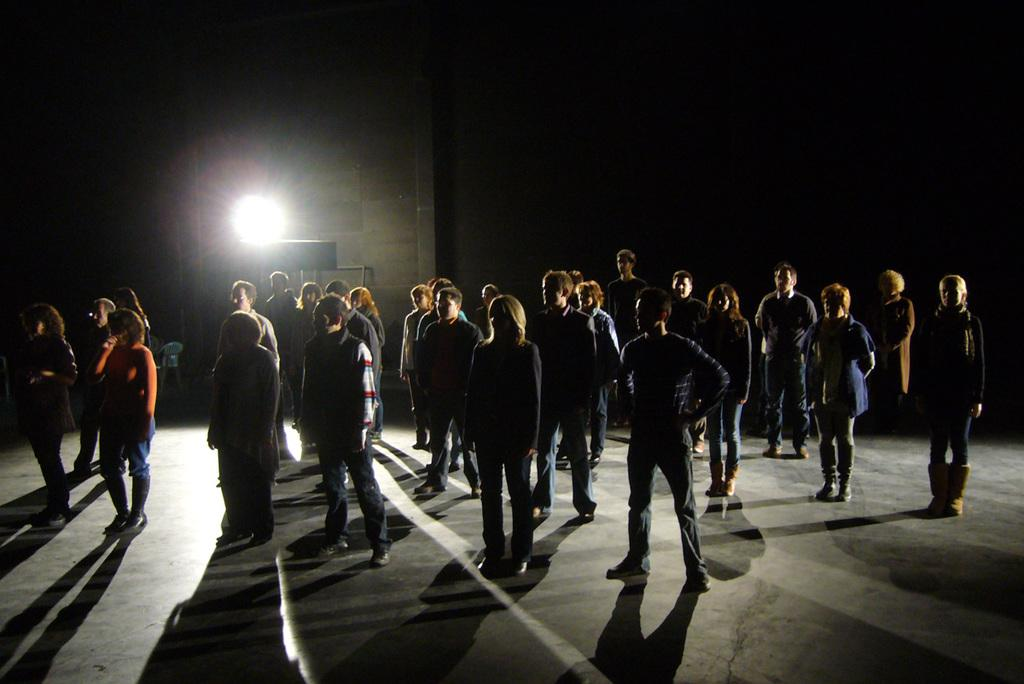What are the people in the image doing? The people in the image are standing on the floor. Can you describe the lighting in the image? There is a light visible in the image. What is present in the background of the image? There is a wall in the image. What is the lady holding in the image? The lady is holding a microphone in the image. What type of toothbrush is the lady using while holding the microphone in the image? There is no toothbrush present in the image; the lady is holding a microphone. 